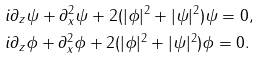<formula> <loc_0><loc_0><loc_500><loc_500>& i \partial _ { z } \psi + \partial ^ { 2 } _ { x } \psi + 2 ( | \phi | ^ { 2 } + | \psi | ^ { 2 } ) \psi = 0 , \\ & i \partial _ { z } \phi + \partial ^ { 2 } _ { x } \phi + 2 ( | \phi | ^ { 2 } + | \psi | ^ { 2 } ) \phi = 0 .</formula> 